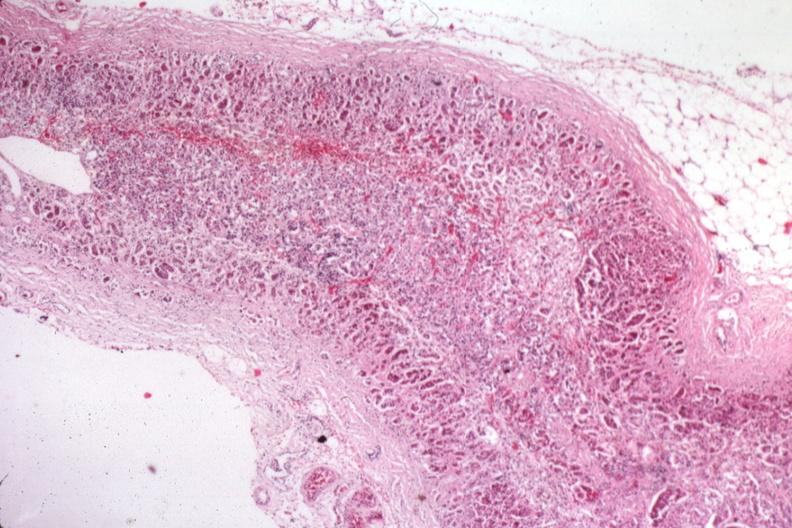does this image show atrophy secondary to corticoid therapy?
Answer the question using a single word or phrase. Yes 